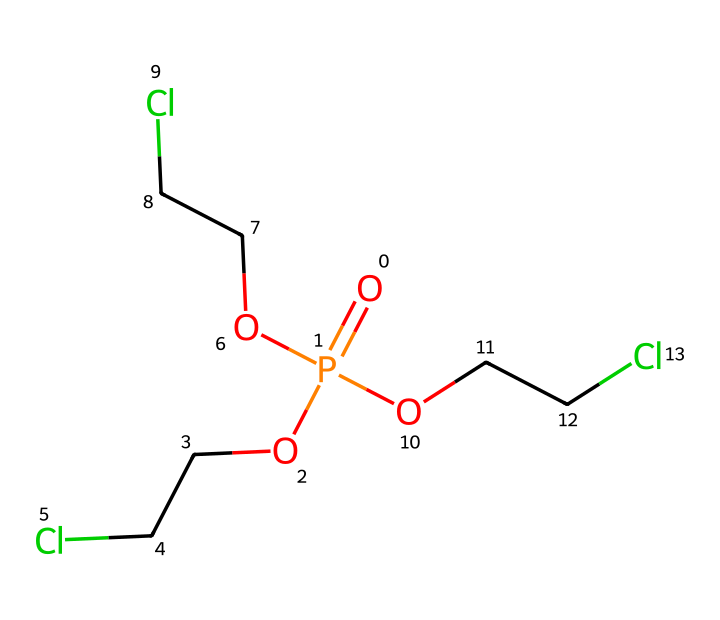What is the molecular formula of tris(2-chloroethyl) phosphate? The formula can be determined by counting the atoms in the chemical structure. The chemical comprises phosphorus (1), oxygen (4), chlorine (3), and carbon (6) as follows: P is represented directly, O's from the phosphate group, Cl from the 2-chloroethyl groups, and C from the ethyl groups. Therefore, the molecular formula is C6H12Cl3O4P.
Answer: C6H12Cl3O4P How many chlorine atoms are present in tris(2-chloroethyl) phosphate? By examining the structural representation, there is a clear presence of three chlorine atoms attached to the ethyl groups in the molecule. Each 2-chloroethyl group contributes one chlorine atom.
Answer: 3 What type of functional groups are present in this compound? The compound contains phosphate, which involves the phosphoric acid derivative (indicating a phosphate group), along with the chloroethyl groups (indicating alkyl halides with chlorine atoms). Thus, the functional groups present are phosphate and chloroalkane.
Answer: phosphate, chloroalkane Is tris(2-chloroethyl) phosphate likely to be a solid, liquid, or gas at room temperature? Assessing the properties typical of similar organophosphate compounds indicates that they are generally volatile and used in various applications, often as liquids. Therefore, it is reasonable to conclude that this compound will be a liquid at room temperature.
Answer: liquid What role does tris(2-chloroethyl) phosphate serve in microphone covers and stage equipment? Tris(2-chloroethyl) phosphate's chemical properties make it an effective flame retardant, as it can reduce the flammability of materials, thereby enhancing safety in electronic applications like microphone covers and stage equipment.
Answer: flame retardant What is the total number of oxygen atoms in the structure of tris(2-chloroethyl) phosphate? The chemical structure shows that there are four oxygen atoms present, as can be identified from the phosphate group. Each of the three ethyl phosphate bonds includes an oxygen while the fourth is part of the phosphate backbone.
Answer: 4 